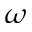<formula> <loc_0><loc_0><loc_500><loc_500>\omega</formula> 